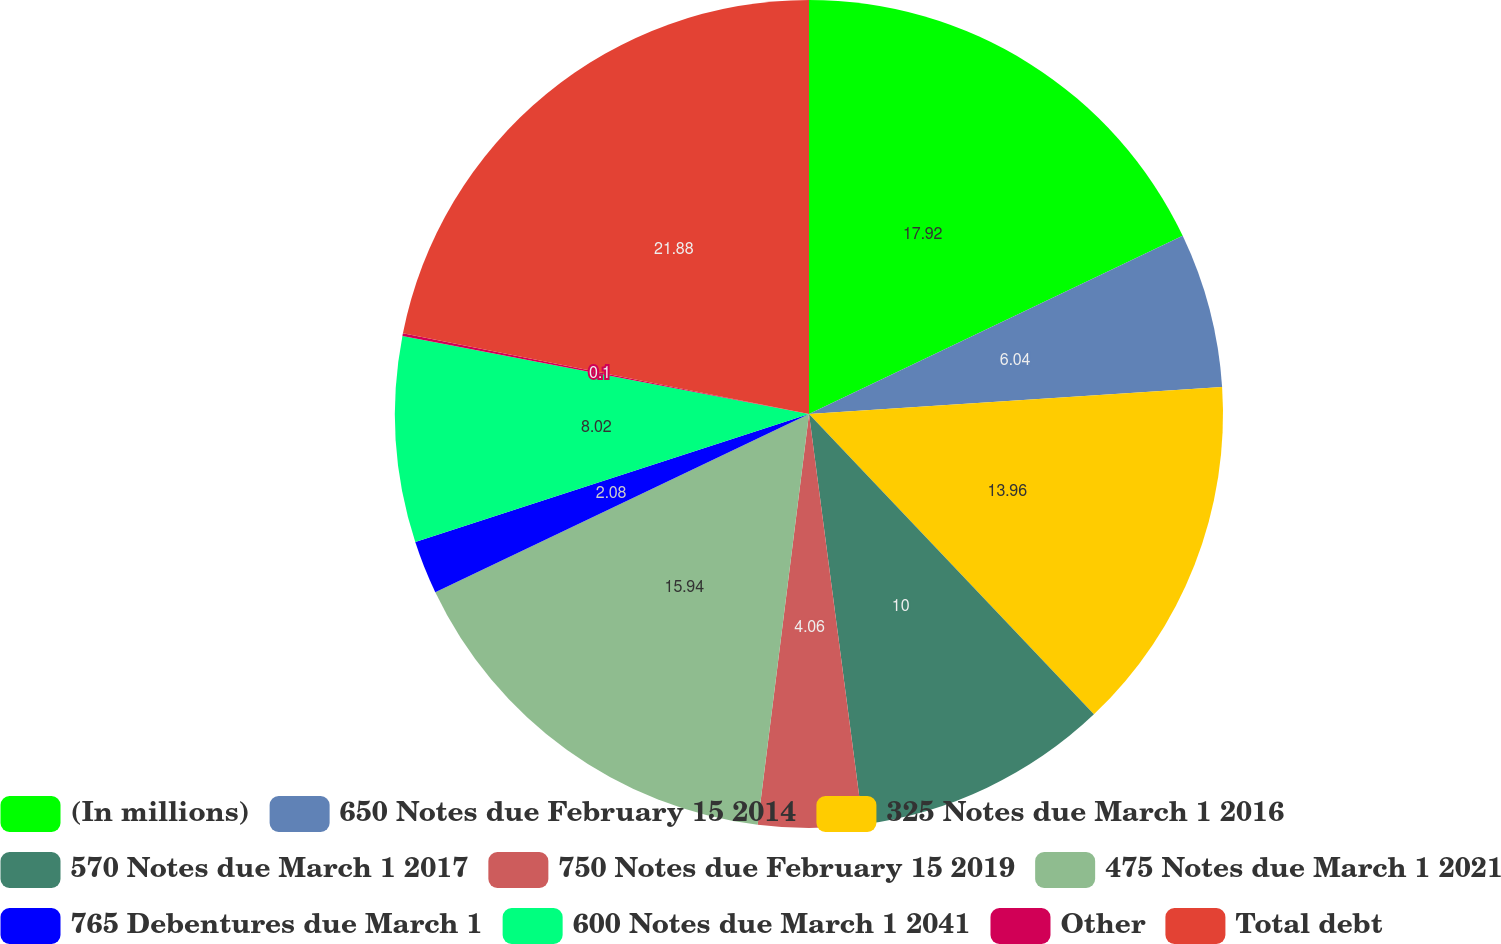Convert chart. <chart><loc_0><loc_0><loc_500><loc_500><pie_chart><fcel>(In millions)<fcel>650 Notes due February 15 2014<fcel>325 Notes due March 1 2016<fcel>570 Notes due March 1 2017<fcel>750 Notes due February 15 2019<fcel>475 Notes due March 1 2021<fcel>765 Debentures due March 1<fcel>600 Notes due March 1 2041<fcel>Other<fcel>Total debt<nl><fcel>17.92%<fcel>6.04%<fcel>13.96%<fcel>10.0%<fcel>4.06%<fcel>15.94%<fcel>2.08%<fcel>8.02%<fcel>0.1%<fcel>21.88%<nl></chart> 